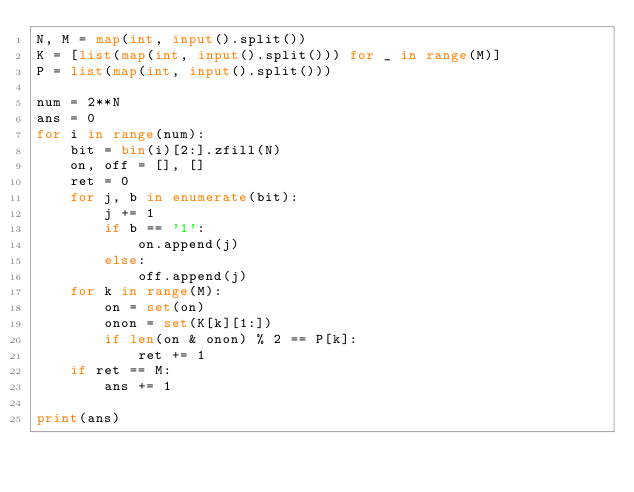Convert code to text. <code><loc_0><loc_0><loc_500><loc_500><_Python_>N, M = map(int, input().split())
K = [list(map(int, input().split())) for _ in range(M)]
P = list(map(int, input().split()))

num = 2**N
ans = 0
for i in range(num):
    bit = bin(i)[2:].zfill(N)
    on, off = [], []
    ret = 0
    for j, b in enumerate(bit):
        j += 1
        if b == '1':
            on.append(j)
        else:
            off.append(j)
    for k in range(M):
        on = set(on)
        onon = set(K[k][1:])
        if len(on & onon) % 2 == P[k]:
            ret += 1
    if ret == M:
        ans += 1

print(ans)
</code> 